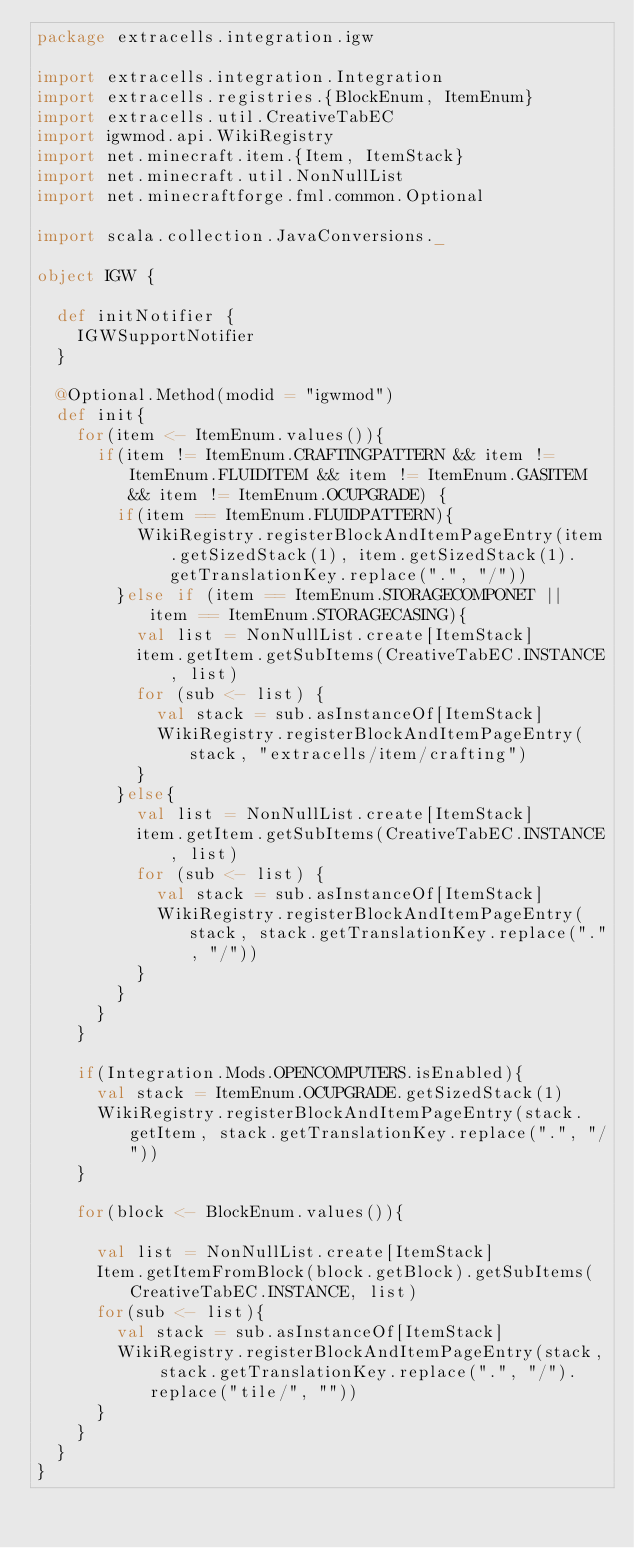<code> <loc_0><loc_0><loc_500><loc_500><_Scala_>package extracells.integration.igw

import extracells.integration.Integration
import extracells.registries.{BlockEnum, ItemEnum}
import extracells.util.CreativeTabEC
import igwmod.api.WikiRegistry
import net.minecraft.item.{Item, ItemStack}
import net.minecraft.util.NonNullList
import net.minecraftforge.fml.common.Optional

import scala.collection.JavaConversions._

object IGW {

  def initNotifier {
    IGWSupportNotifier
  }

  @Optional.Method(modid = "igwmod")
  def init{
    for(item <- ItemEnum.values()){
      if(item != ItemEnum.CRAFTINGPATTERN && item != ItemEnum.FLUIDITEM && item != ItemEnum.GASITEM && item != ItemEnum.OCUPGRADE) {
        if(item == ItemEnum.FLUIDPATTERN){
          WikiRegistry.registerBlockAndItemPageEntry(item.getSizedStack(1), item.getSizedStack(1).getTranslationKey.replace(".", "/"))
        }else if (item == ItemEnum.STORAGECOMPONET || item == ItemEnum.STORAGECASING){
          val list = NonNullList.create[ItemStack]
          item.getItem.getSubItems(CreativeTabEC.INSTANCE, list)
          for (sub <- list) {
            val stack = sub.asInstanceOf[ItemStack]
            WikiRegistry.registerBlockAndItemPageEntry(stack, "extracells/item/crafting")
          }
        }else{
          val list = NonNullList.create[ItemStack]
          item.getItem.getSubItems(CreativeTabEC.INSTANCE, list)
          for (sub <- list) {
            val stack = sub.asInstanceOf[ItemStack]
            WikiRegistry.registerBlockAndItemPageEntry(stack, stack.getTranslationKey.replace(".", "/"))
          }
        }
      }
    }

    if(Integration.Mods.OPENCOMPUTERS.isEnabled){
      val stack = ItemEnum.OCUPGRADE.getSizedStack(1)
      WikiRegistry.registerBlockAndItemPageEntry(stack.getItem, stack.getTranslationKey.replace(".", "/"))
    }

    for(block <- BlockEnum.values()){

      val list = NonNullList.create[ItemStack]
      Item.getItemFromBlock(block.getBlock).getSubItems( CreativeTabEC.INSTANCE, list)
      for(sub <- list){
        val stack = sub.asInstanceOf[ItemStack]
        WikiRegistry.registerBlockAndItemPageEntry(stack, stack.getTranslationKey.replace(".", "/").replace("tile/", ""))
      }
    }
  }
}
</code> 